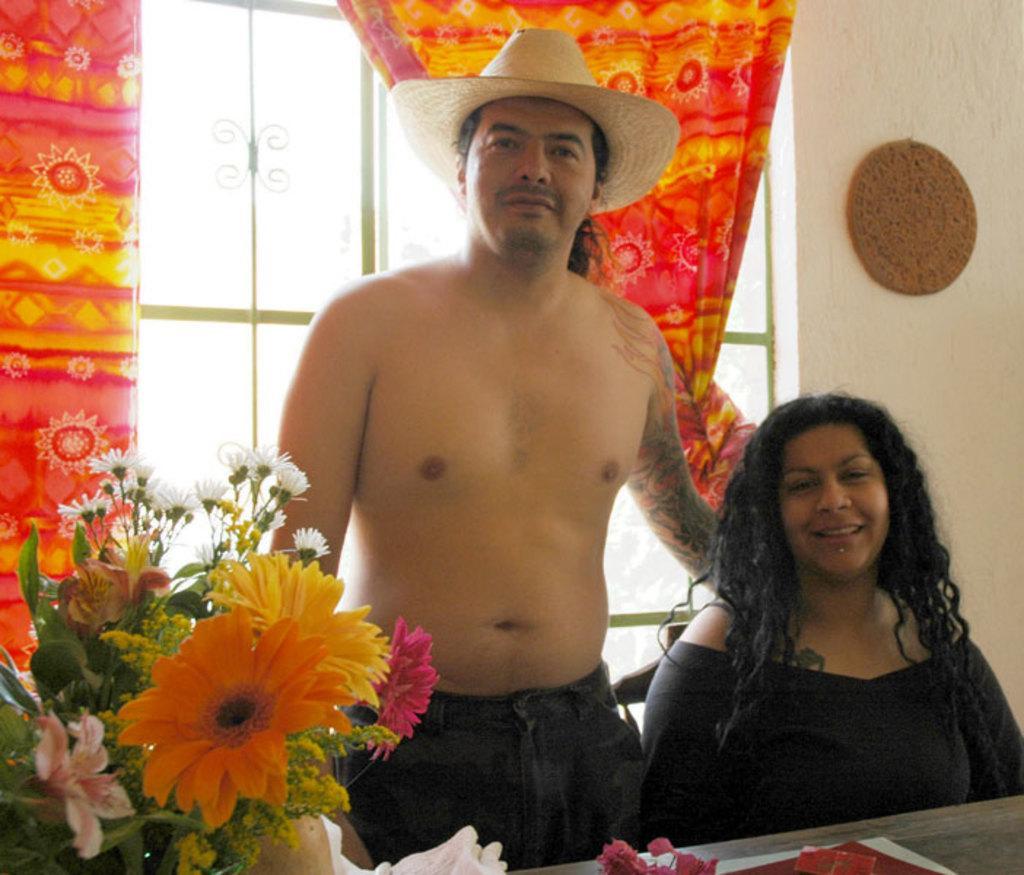Could you give a brief overview of what you see in this image? In this picture we can see a man, woman, they are smiling and woman is sitting on a chair, in front of them we can see a platform, flower vase and some objects and in the background we can see a wall, window, curtains. 